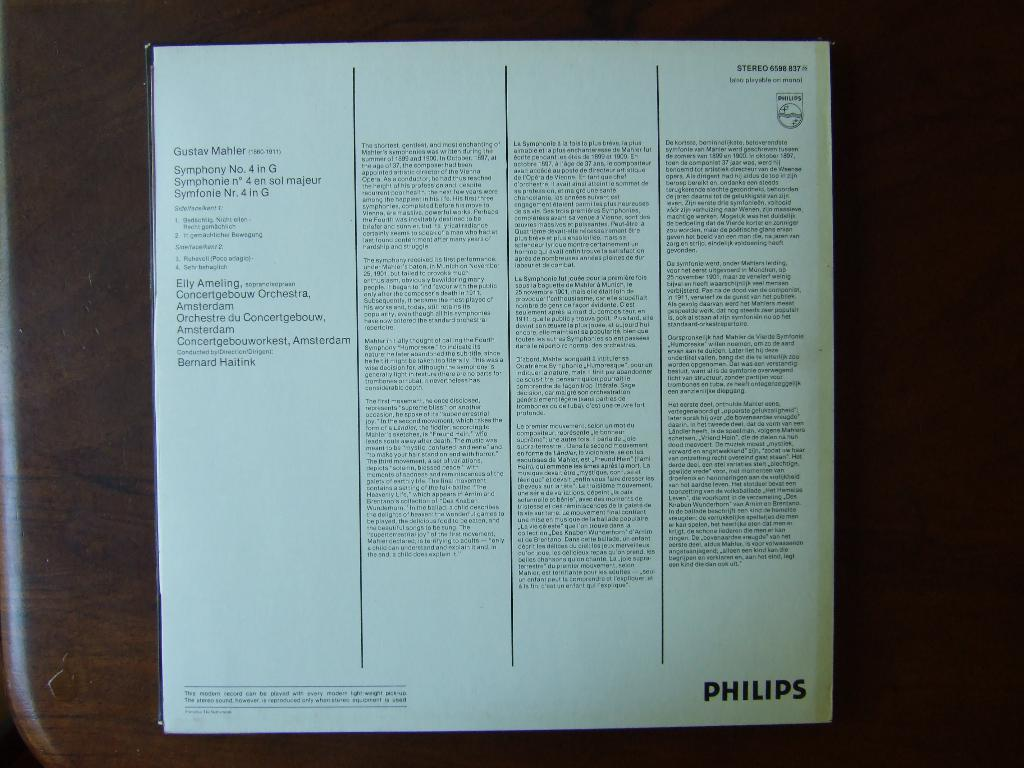<image>
Offer a succinct explanation of the picture presented. a page from a pamphlet that has Philips on the bottom right of it 